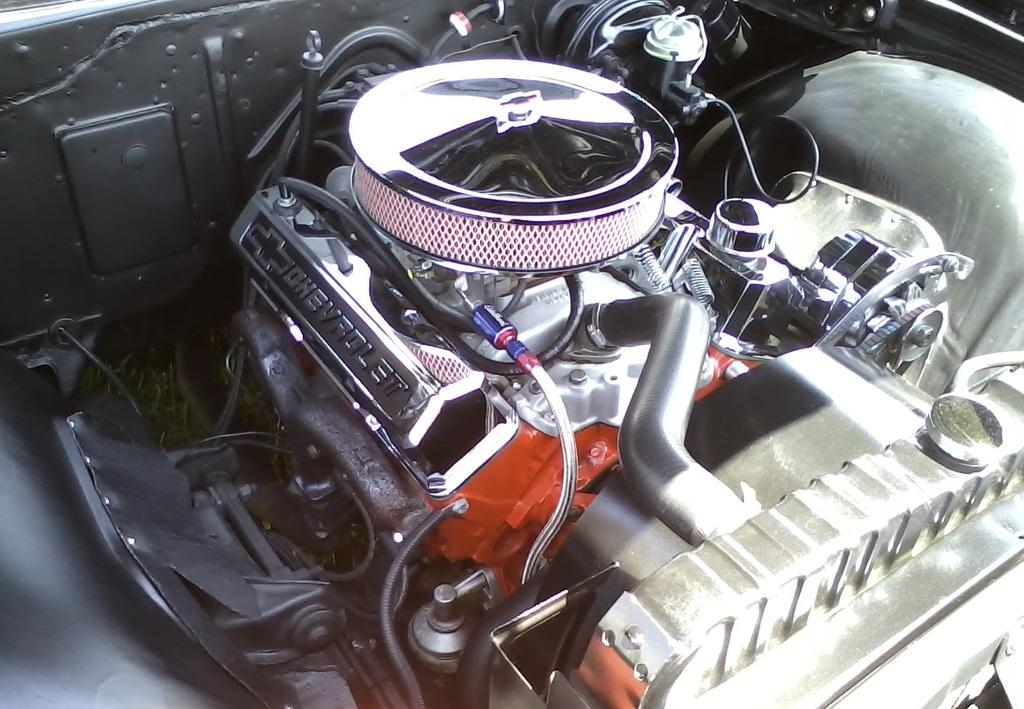What is the main subject of the image? The main subject of the image is an engine. What type of object does the engine belong to? The engine belongs to a vehicle. How many robins can be seen flying around the engine in the image? There are no robins present in the image; it features an engine belonging to a vehicle. 